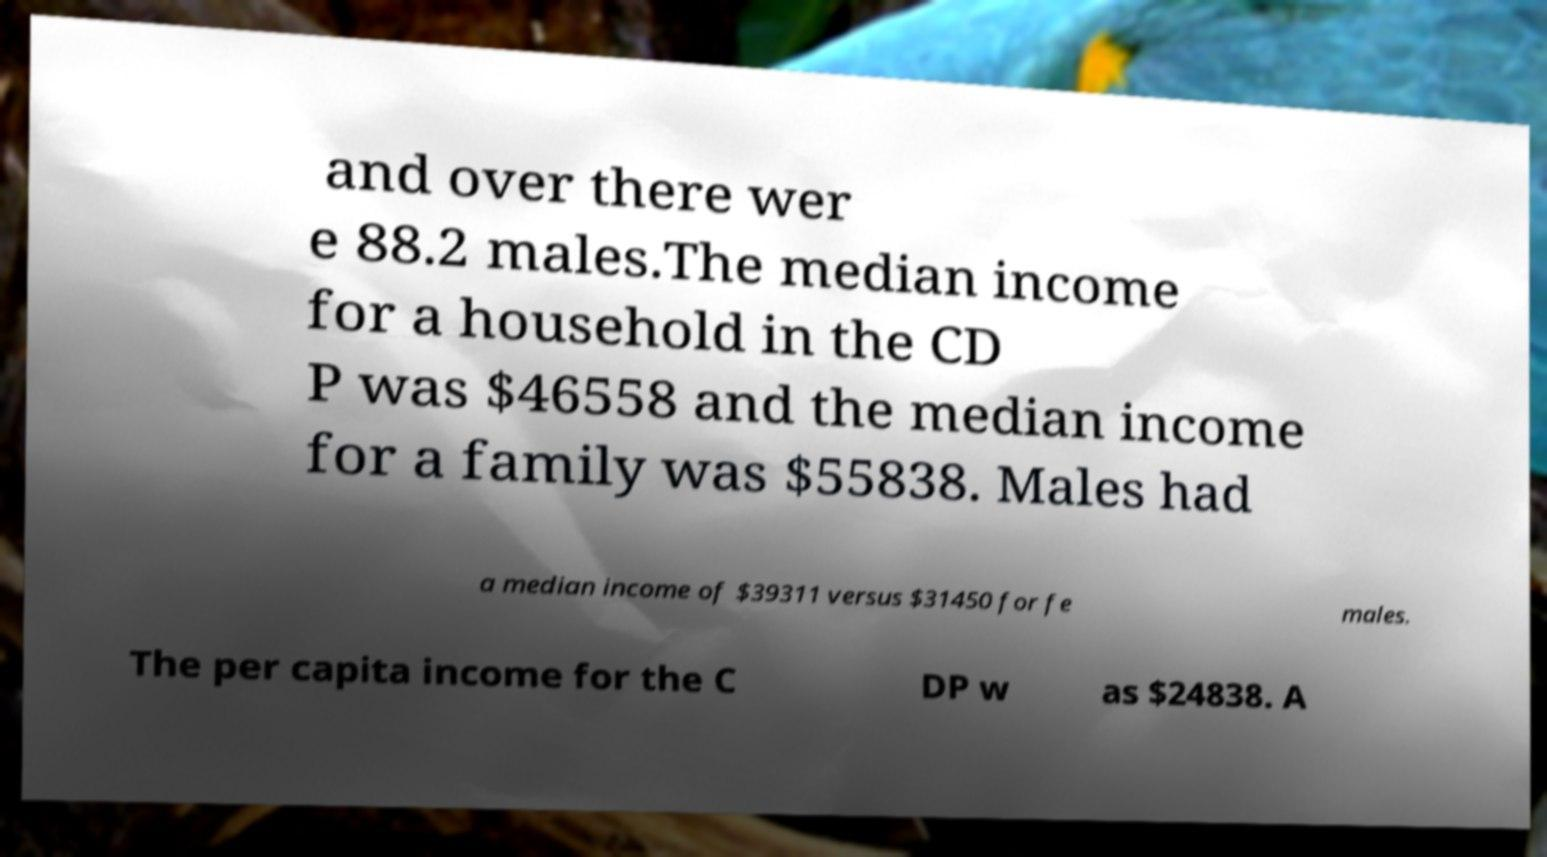Can you read and provide the text displayed in the image?This photo seems to have some interesting text. Can you extract and type it out for me? and over there wer e 88.2 males.The median income for a household in the CD P was $46558 and the median income for a family was $55838. Males had a median income of $39311 versus $31450 for fe males. The per capita income for the C DP w as $24838. A 